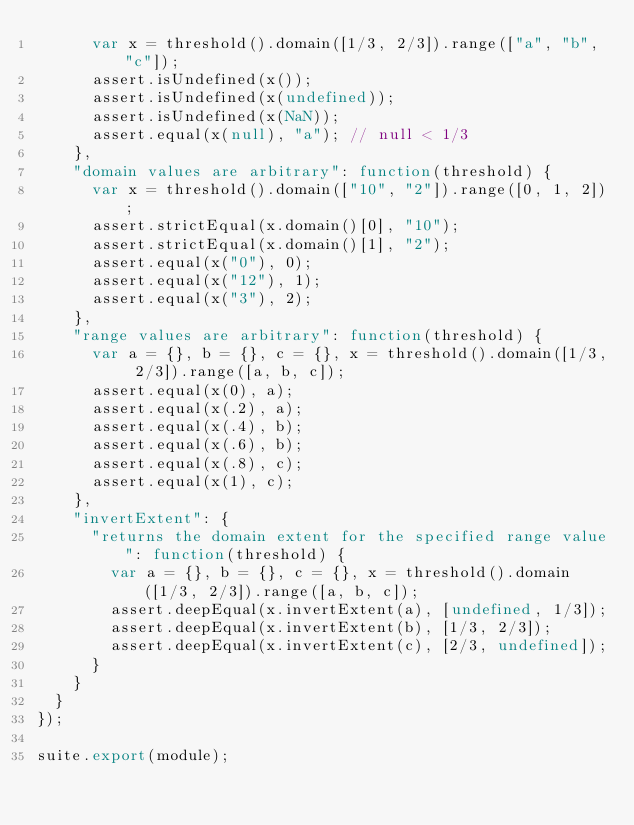Convert code to text. <code><loc_0><loc_0><loc_500><loc_500><_JavaScript_>      var x = threshold().domain([1/3, 2/3]).range(["a", "b", "c"]);
      assert.isUndefined(x());
      assert.isUndefined(x(undefined));
      assert.isUndefined(x(NaN));
      assert.equal(x(null), "a"); // null < 1/3
    },
    "domain values are arbitrary": function(threshold) {
      var x = threshold().domain(["10", "2"]).range([0, 1, 2]);
      assert.strictEqual(x.domain()[0], "10");
      assert.strictEqual(x.domain()[1], "2");
      assert.equal(x("0"), 0);
      assert.equal(x("12"), 1);
      assert.equal(x("3"), 2);
    },
    "range values are arbitrary": function(threshold) {
      var a = {}, b = {}, c = {}, x = threshold().domain([1/3, 2/3]).range([a, b, c]);
      assert.equal(x(0), a);
      assert.equal(x(.2), a);
      assert.equal(x(.4), b);
      assert.equal(x(.6), b);
      assert.equal(x(.8), c);
      assert.equal(x(1), c);
    },
    "invertExtent": {
      "returns the domain extent for the specified range value": function(threshold) {
        var a = {}, b = {}, c = {}, x = threshold().domain([1/3, 2/3]).range([a, b, c]);
        assert.deepEqual(x.invertExtent(a), [undefined, 1/3]);
        assert.deepEqual(x.invertExtent(b), [1/3, 2/3]);
        assert.deepEqual(x.invertExtent(c), [2/3, undefined]);
      }
    }
  }
});

suite.export(module);
</code> 